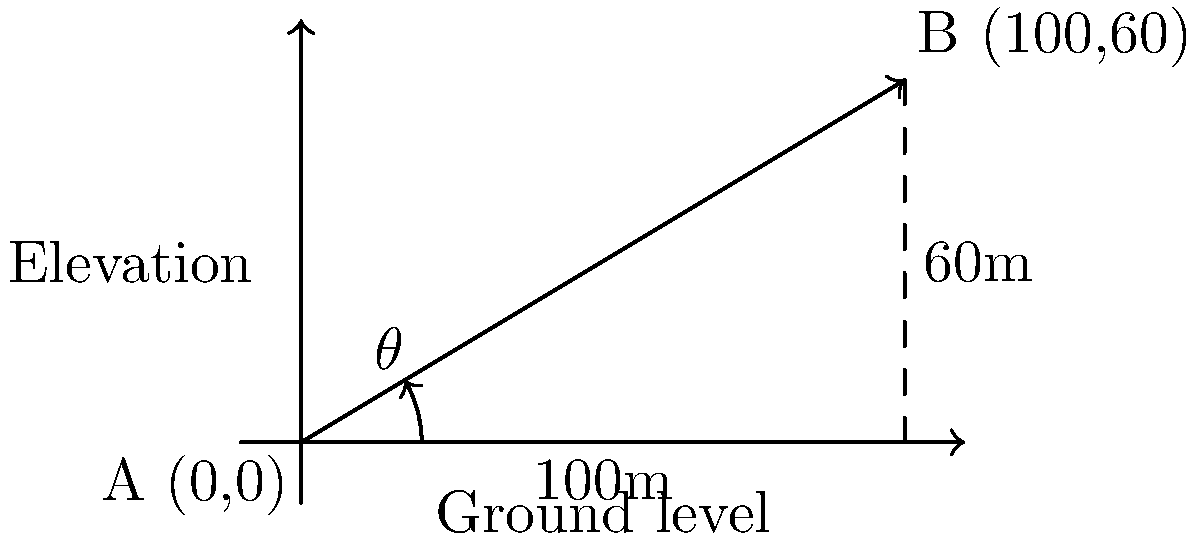A military drone needs to fly from point A (0,0) to point B (100,60), where the horizontal distance is 100 meters and the vertical elevation difference is 60 meters. Calculate the optimal angle $\theta$ for the drone's flight path to minimize energy consumption. To find the optimal angle for the drone's flight path, we need to use trigonometry. The flight path forms a right triangle with the ground and the elevation difference.

Step 1: Identify the triangle's sides
- Adjacent side (horizontal distance) = 100 meters
- Opposite side (elevation difference) = 60 meters
- Hypotenuse = direct flight path (to be calculated)

Step 2: Determine which trigonometric function to use
We need to find the angle using the opposite and adjacent sides, so we'll use the tangent function.

Step 3: Set up the equation
$\tan(\theta) = \frac{\text{opposite}}{\text{adjacent}} = \frac{60}{100}$

Step 4: Solve for $\theta$ using the inverse tangent (arctangent) function
$\theta = \tan^{-1}(\frac{60}{100})$

Step 5: Calculate the result
$\theta = \tan^{-1}(0.6) \approx 30.96°$

The optimal angle for the drone's flight path is approximately 30.96 degrees.
Answer: $\theta \approx 30.96°$ 